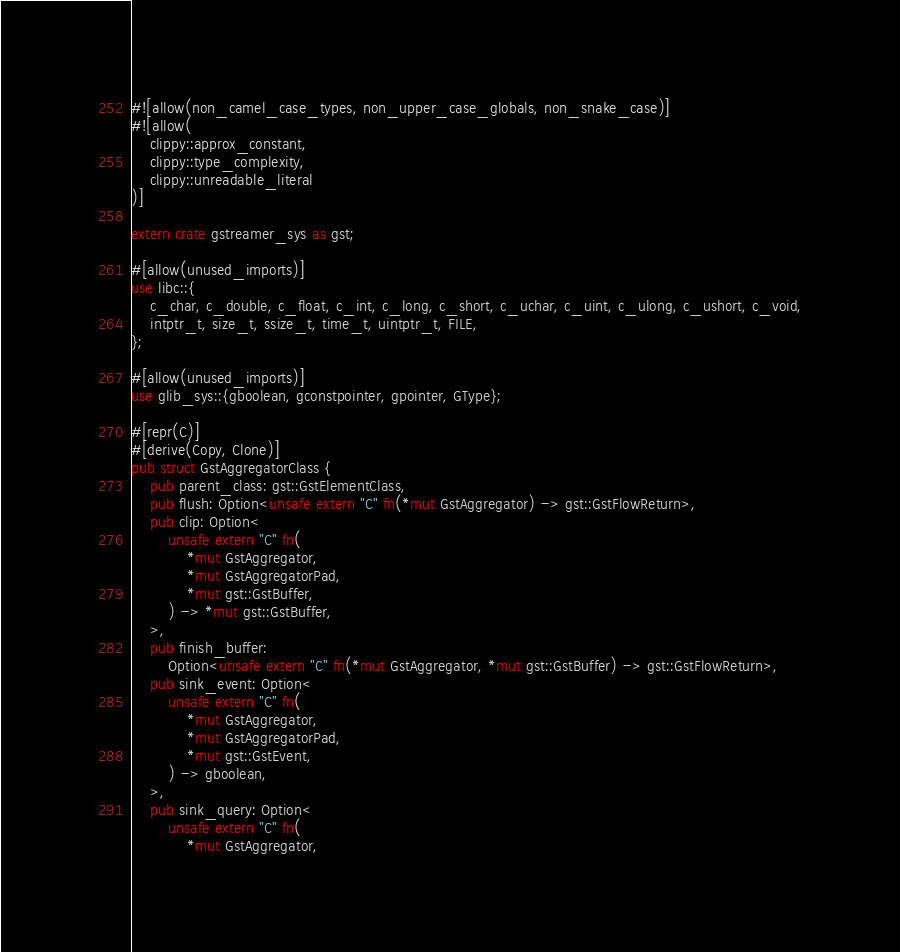Convert code to text. <code><loc_0><loc_0><loc_500><loc_500><_Rust_>#![allow(non_camel_case_types, non_upper_case_globals, non_snake_case)]
#![allow(
    clippy::approx_constant,
    clippy::type_complexity,
    clippy::unreadable_literal
)]

extern crate gstreamer_sys as gst;

#[allow(unused_imports)]
use libc::{
    c_char, c_double, c_float, c_int, c_long, c_short, c_uchar, c_uint, c_ulong, c_ushort, c_void,
    intptr_t, size_t, ssize_t, time_t, uintptr_t, FILE,
};

#[allow(unused_imports)]
use glib_sys::{gboolean, gconstpointer, gpointer, GType};

#[repr(C)]
#[derive(Copy, Clone)]
pub struct GstAggregatorClass {
    pub parent_class: gst::GstElementClass,
    pub flush: Option<unsafe extern "C" fn(*mut GstAggregator) -> gst::GstFlowReturn>,
    pub clip: Option<
        unsafe extern "C" fn(
            *mut GstAggregator,
            *mut GstAggregatorPad,
            *mut gst::GstBuffer,
        ) -> *mut gst::GstBuffer,
    >,
    pub finish_buffer:
        Option<unsafe extern "C" fn(*mut GstAggregator, *mut gst::GstBuffer) -> gst::GstFlowReturn>,
    pub sink_event: Option<
        unsafe extern "C" fn(
            *mut GstAggregator,
            *mut GstAggregatorPad,
            *mut gst::GstEvent,
        ) -> gboolean,
    >,
    pub sink_query: Option<
        unsafe extern "C" fn(
            *mut GstAggregator,</code> 